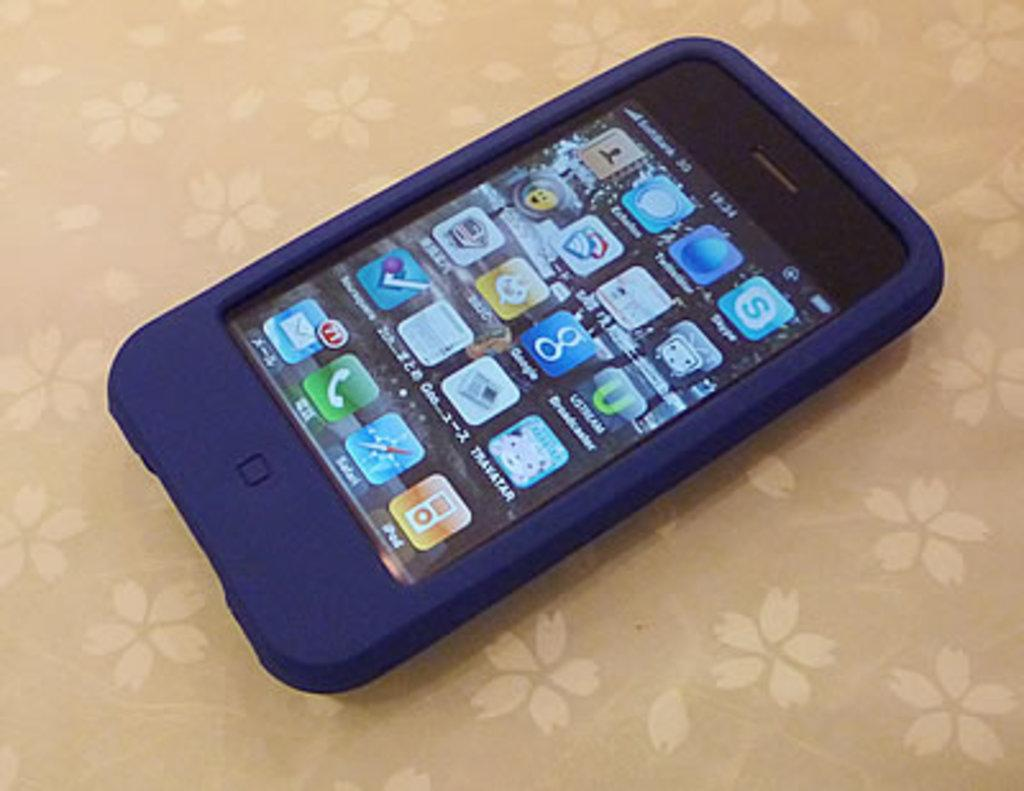<image>
Render a clear and concise summary of the photo. a cell phone in a blue rubber case with icons for Google on the display 